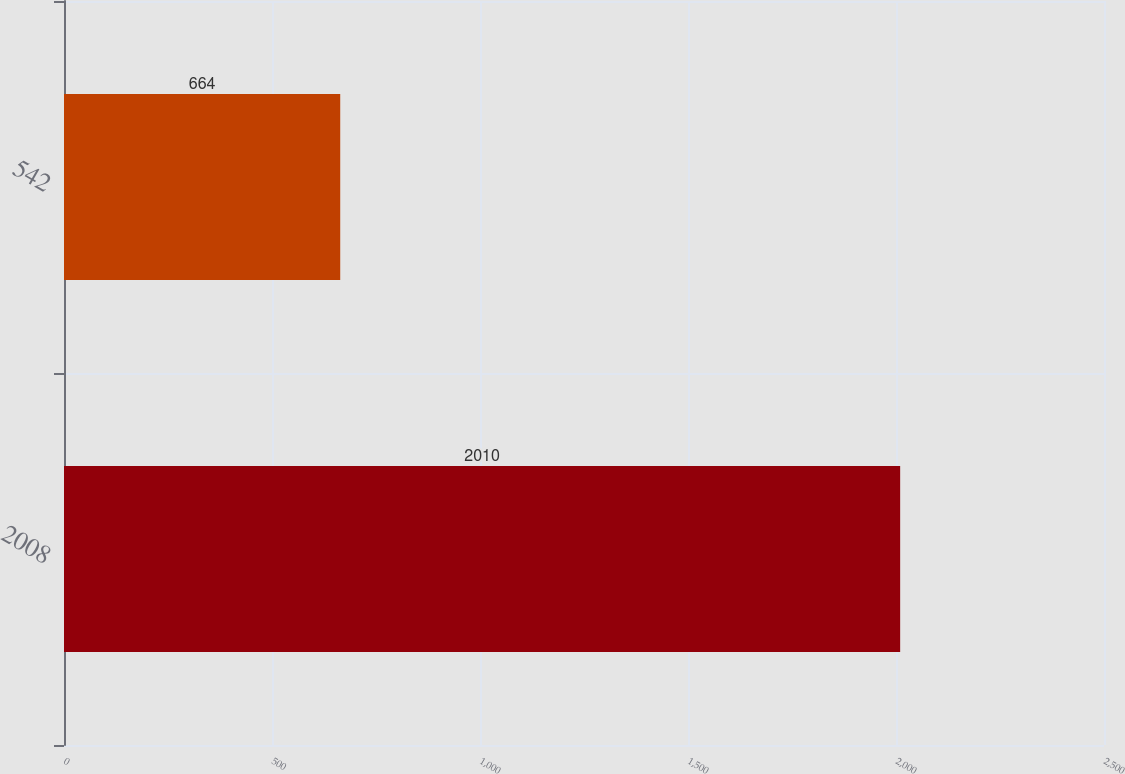<chart> <loc_0><loc_0><loc_500><loc_500><bar_chart><fcel>2008<fcel>542<nl><fcel>2010<fcel>664<nl></chart> 